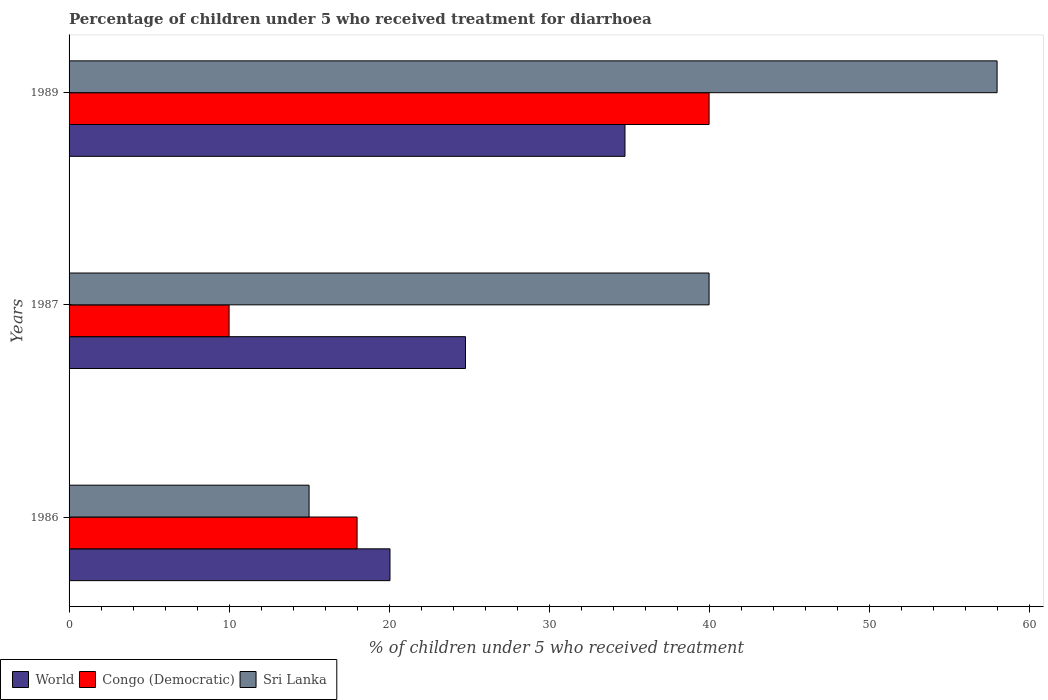How many groups of bars are there?
Offer a terse response. 3. Are the number of bars on each tick of the Y-axis equal?
Keep it short and to the point. Yes. How many bars are there on the 3rd tick from the top?
Your answer should be compact. 3. Across all years, what is the maximum percentage of children who received treatment for diarrhoea  in Congo (Democratic)?
Your answer should be compact. 40. Across all years, what is the minimum percentage of children who received treatment for diarrhoea  in Sri Lanka?
Provide a succinct answer. 15. In which year was the percentage of children who received treatment for diarrhoea  in Sri Lanka maximum?
Your answer should be compact. 1989. In which year was the percentage of children who received treatment for diarrhoea  in World minimum?
Give a very brief answer. 1986. What is the total percentage of children who received treatment for diarrhoea  in Congo (Democratic) in the graph?
Ensure brevity in your answer.  68. What is the difference between the percentage of children who received treatment for diarrhoea  in Congo (Democratic) in 1986 and that in 1989?
Your answer should be compact. -22. What is the average percentage of children who received treatment for diarrhoea  in World per year?
Your response must be concise. 26.53. In the year 1987, what is the difference between the percentage of children who received treatment for diarrhoea  in World and percentage of children who received treatment for diarrhoea  in Sri Lanka?
Your answer should be compact. -15.22. In how many years, is the percentage of children who received treatment for diarrhoea  in World greater than 40 %?
Ensure brevity in your answer.  0. What is the ratio of the percentage of children who received treatment for diarrhoea  in Congo (Democratic) in 1987 to that in 1989?
Your answer should be very brief. 0.25. What is the difference between the highest and the second highest percentage of children who received treatment for diarrhoea  in Sri Lanka?
Keep it short and to the point. 18. What is the difference between the highest and the lowest percentage of children who received treatment for diarrhoea  in World?
Your response must be concise. 14.69. In how many years, is the percentage of children who received treatment for diarrhoea  in World greater than the average percentage of children who received treatment for diarrhoea  in World taken over all years?
Provide a succinct answer. 1. Is the sum of the percentage of children who received treatment for diarrhoea  in Sri Lanka in 1986 and 1987 greater than the maximum percentage of children who received treatment for diarrhoea  in Congo (Democratic) across all years?
Offer a very short reply. Yes. What does the 2nd bar from the top in 1986 represents?
Make the answer very short. Congo (Democratic). What does the 1st bar from the bottom in 1989 represents?
Ensure brevity in your answer.  World. How many bars are there?
Provide a succinct answer. 9. How many years are there in the graph?
Offer a very short reply. 3. What is the difference between two consecutive major ticks on the X-axis?
Keep it short and to the point. 10. Are the values on the major ticks of X-axis written in scientific E-notation?
Offer a very short reply. No. Does the graph contain grids?
Offer a terse response. No. Where does the legend appear in the graph?
Offer a terse response. Bottom left. What is the title of the graph?
Keep it short and to the point. Percentage of children under 5 who received treatment for diarrhoea. What is the label or title of the X-axis?
Your answer should be compact. % of children under 5 who received treatment. What is the label or title of the Y-axis?
Your response must be concise. Years. What is the % of children under 5 who received treatment in World in 1986?
Keep it short and to the point. 20.06. What is the % of children under 5 who received treatment in World in 1987?
Offer a terse response. 24.78. What is the % of children under 5 who received treatment of Congo (Democratic) in 1987?
Provide a short and direct response. 10. What is the % of children under 5 who received treatment of World in 1989?
Provide a short and direct response. 34.74. What is the % of children under 5 who received treatment of Congo (Democratic) in 1989?
Your answer should be compact. 40. What is the % of children under 5 who received treatment in Sri Lanka in 1989?
Provide a short and direct response. 58. Across all years, what is the maximum % of children under 5 who received treatment in World?
Make the answer very short. 34.74. Across all years, what is the minimum % of children under 5 who received treatment in World?
Keep it short and to the point. 20.06. Across all years, what is the minimum % of children under 5 who received treatment in Sri Lanka?
Your answer should be very brief. 15. What is the total % of children under 5 who received treatment of World in the graph?
Ensure brevity in your answer.  79.58. What is the total % of children under 5 who received treatment of Congo (Democratic) in the graph?
Ensure brevity in your answer.  68. What is the total % of children under 5 who received treatment in Sri Lanka in the graph?
Your answer should be very brief. 113. What is the difference between the % of children under 5 who received treatment of World in 1986 and that in 1987?
Give a very brief answer. -4.72. What is the difference between the % of children under 5 who received treatment in Congo (Democratic) in 1986 and that in 1987?
Provide a succinct answer. 8. What is the difference between the % of children under 5 who received treatment in Sri Lanka in 1986 and that in 1987?
Offer a terse response. -25. What is the difference between the % of children under 5 who received treatment in World in 1986 and that in 1989?
Offer a very short reply. -14.69. What is the difference between the % of children under 5 who received treatment of Congo (Democratic) in 1986 and that in 1989?
Offer a very short reply. -22. What is the difference between the % of children under 5 who received treatment in Sri Lanka in 1986 and that in 1989?
Keep it short and to the point. -43. What is the difference between the % of children under 5 who received treatment of World in 1987 and that in 1989?
Offer a terse response. -9.97. What is the difference between the % of children under 5 who received treatment of Congo (Democratic) in 1987 and that in 1989?
Your response must be concise. -30. What is the difference between the % of children under 5 who received treatment of World in 1986 and the % of children under 5 who received treatment of Congo (Democratic) in 1987?
Your response must be concise. 10.06. What is the difference between the % of children under 5 who received treatment in World in 1986 and the % of children under 5 who received treatment in Sri Lanka in 1987?
Your answer should be compact. -19.94. What is the difference between the % of children under 5 who received treatment of Congo (Democratic) in 1986 and the % of children under 5 who received treatment of Sri Lanka in 1987?
Provide a short and direct response. -22. What is the difference between the % of children under 5 who received treatment of World in 1986 and the % of children under 5 who received treatment of Congo (Democratic) in 1989?
Give a very brief answer. -19.94. What is the difference between the % of children under 5 who received treatment of World in 1986 and the % of children under 5 who received treatment of Sri Lanka in 1989?
Make the answer very short. -37.94. What is the difference between the % of children under 5 who received treatment of World in 1987 and the % of children under 5 who received treatment of Congo (Democratic) in 1989?
Offer a terse response. -15.22. What is the difference between the % of children under 5 who received treatment of World in 1987 and the % of children under 5 who received treatment of Sri Lanka in 1989?
Keep it short and to the point. -33.22. What is the difference between the % of children under 5 who received treatment in Congo (Democratic) in 1987 and the % of children under 5 who received treatment in Sri Lanka in 1989?
Make the answer very short. -48. What is the average % of children under 5 who received treatment of World per year?
Give a very brief answer. 26.53. What is the average % of children under 5 who received treatment of Congo (Democratic) per year?
Your answer should be compact. 22.67. What is the average % of children under 5 who received treatment of Sri Lanka per year?
Provide a short and direct response. 37.67. In the year 1986, what is the difference between the % of children under 5 who received treatment of World and % of children under 5 who received treatment of Congo (Democratic)?
Provide a short and direct response. 2.06. In the year 1986, what is the difference between the % of children under 5 who received treatment of World and % of children under 5 who received treatment of Sri Lanka?
Keep it short and to the point. 5.06. In the year 1986, what is the difference between the % of children under 5 who received treatment of Congo (Democratic) and % of children under 5 who received treatment of Sri Lanka?
Offer a very short reply. 3. In the year 1987, what is the difference between the % of children under 5 who received treatment of World and % of children under 5 who received treatment of Congo (Democratic)?
Your answer should be compact. 14.78. In the year 1987, what is the difference between the % of children under 5 who received treatment of World and % of children under 5 who received treatment of Sri Lanka?
Keep it short and to the point. -15.22. In the year 1987, what is the difference between the % of children under 5 who received treatment of Congo (Democratic) and % of children under 5 who received treatment of Sri Lanka?
Offer a terse response. -30. In the year 1989, what is the difference between the % of children under 5 who received treatment of World and % of children under 5 who received treatment of Congo (Democratic)?
Ensure brevity in your answer.  -5.26. In the year 1989, what is the difference between the % of children under 5 who received treatment of World and % of children under 5 who received treatment of Sri Lanka?
Ensure brevity in your answer.  -23.26. What is the ratio of the % of children under 5 who received treatment in World in 1986 to that in 1987?
Provide a short and direct response. 0.81. What is the ratio of the % of children under 5 who received treatment of Sri Lanka in 1986 to that in 1987?
Make the answer very short. 0.38. What is the ratio of the % of children under 5 who received treatment of World in 1986 to that in 1989?
Ensure brevity in your answer.  0.58. What is the ratio of the % of children under 5 who received treatment in Congo (Democratic) in 1986 to that in 1989?
Keep it short and to the point. 0.45. What is the ratio of the % of children under 5 who received treatment in Sri Lanka in 1986 to that in 1989?
Your answer should be very brief. 0.26. What is the ratio of the % of children under 5 who received treatment in World in 1987 to that in 1989?
Provide a short and direct response. 0.71. What is the ratio of the % of children under 5 who received treatment in Sri Lanka in 1987 to that in 1989?
Your answer should be compact. 0.69. What is the difference between the highest and the second highest % of children under 5 who received treatment of World?
Give a very brief answer. 9.97. What is the difference between the highest and the lowest % of children under 5 who received treatment of World?
Give a very brief answer. 14.69. What is the difference between the highest and the lowest % of children under 5 who received treatment in Congo (Democratic)?
Ensure brevity in your answer.  30. 